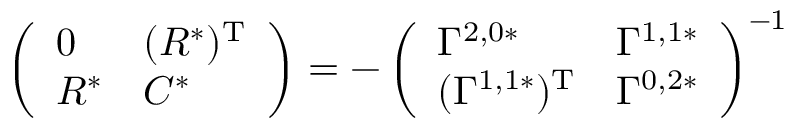Convert formula to latex. <formula><loc_0><loc_0><loc_500><loc_500>\left ( \begin{array} { l l } { 0 } & { ( R ^ { * } ) ^ { T } } \\ { R ^ { * } } & { C ^ { * } } \end{array} \right ) = - \left ( \begin{array} { l l } { \Gamma ^ { 2 , 0 * } } & { \Gamma ^ { 1 , 1 * } } \\ { ( \Gamma ^ { 1 , 1 * } ) ^ { T } } & { \Gamma ^ { 0 , 2 * } } \end{array} \right ) ^ { - 1 }</formula> 